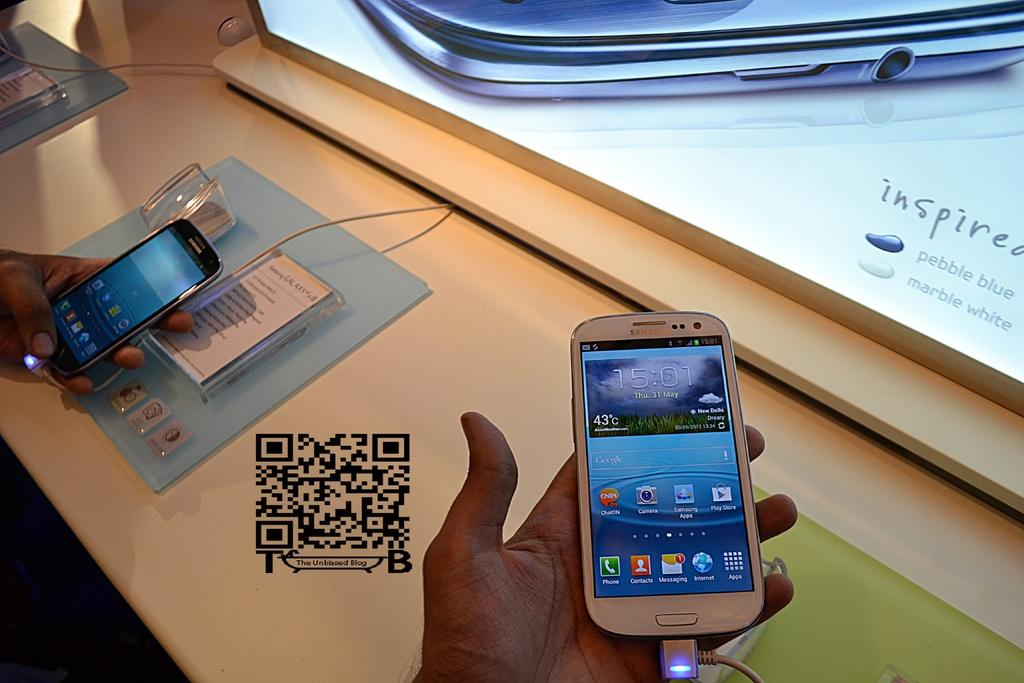<image>
Present a compact description of the photo's key features. Person holding a white phone which has the time at 15:01. 